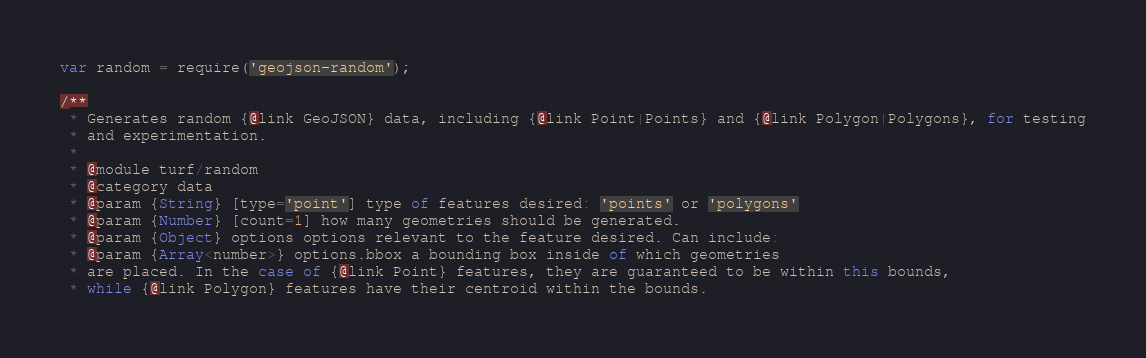<code> <loc_0><loc_0><loc_500><loc_500><_JavaScript_>var random = require('geojson-random');

/**
 * Generates random {@link GeoJSON} data, including {@link Point|Points} and {@link Polygon|Polygons}, for testing
 * and experimentation.
 *
 * @module turf/random
 * @category data
 * @param {String} [type='point'] type of features desired: 'points' or 'polygons'
 * @param {Number} [count=1] how many geometries should be generated.
 * @param {Object} options options relevant to the feature desired. Can include:
 * @param {Array<number>} options.bbox a bounding box inside of which geometries
 * are placed. In the case of {@link Point} features, they are guaranteed to be within this bounds,
 * while {@link Polygon} features have their centroid within the bounds.</code> 